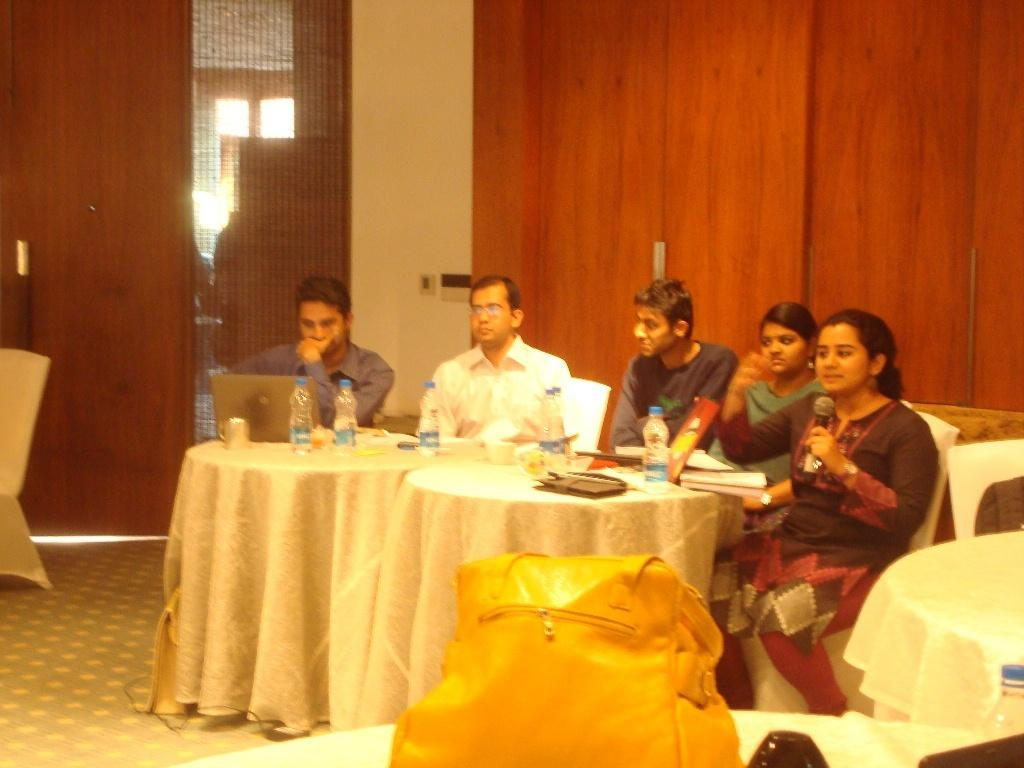What are the people in the image doing? There are people sitting on chairs in the image, with one person talking into a microphone and another person operating a laptop. What object is the person talking into? The person is talking into a microphone. What is the other person using in the image? The other person is using a laptop. Is there anything placed on the microphone? Yes, there is a bag on the microphone. What type of cheese is being used to slip on the chairs in the image? There is no cheese present in the image, and the people are not slipping on the chairs. 